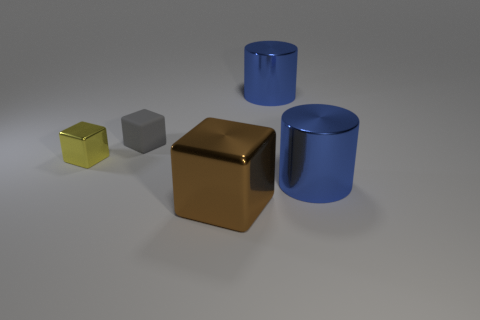What time of day does the lighting in this image suggest? The lighting in the image seems to be artificial and controlled, rather than natural sunlight, suggesting an indoor setting without a specific indication of time of day. Could this lighting be used to create a certain mood or effect? Absolutely, the soft and diffuse lighting creates a calm and neutral atmosphere, which could be used in a setting that requires object focus without emotional distraction. 